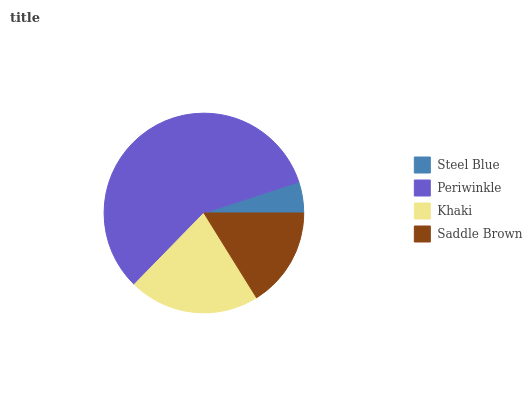Is Steel Blue the minimum?
Answer yes or no. Yes. Is Periwinkle the maximum?
Answer yes or no. Yes. Is Khaki the minimum?
Answer yes or no. No. Is Khaki the maximum?
Answer yes or no. No. Is Periwinkle greater than Khaki?
Answer yes or no. Yes. Is Khaki less than Periwinkle?
Answer yes or no. Yes. Is Khaki greater than Periwinkle?
Answer yes or no. No. Is Periwinkle less than Khaki?
Answer yes or no. No. Is Khaki the high median?
Answer yes or no. Yes. Is Saddle Brown the low median?
Answer yes or no. Yes. Is Saddle Brown the high median?
Answer yes or no. No. Is Khaki the low median?
Answer yes or no. No. 